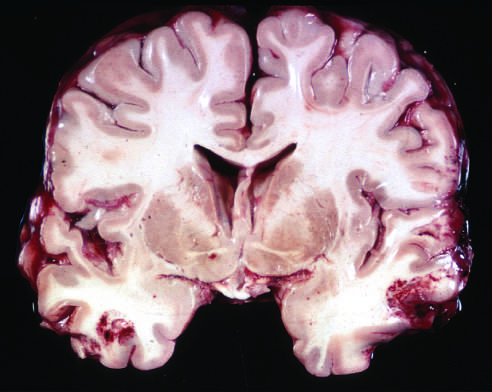re the surrounding acinar structures present in both temporal lobes, with areas of hemorrhage and tissue disruption?
Answer the question using a single word or phrase. No 